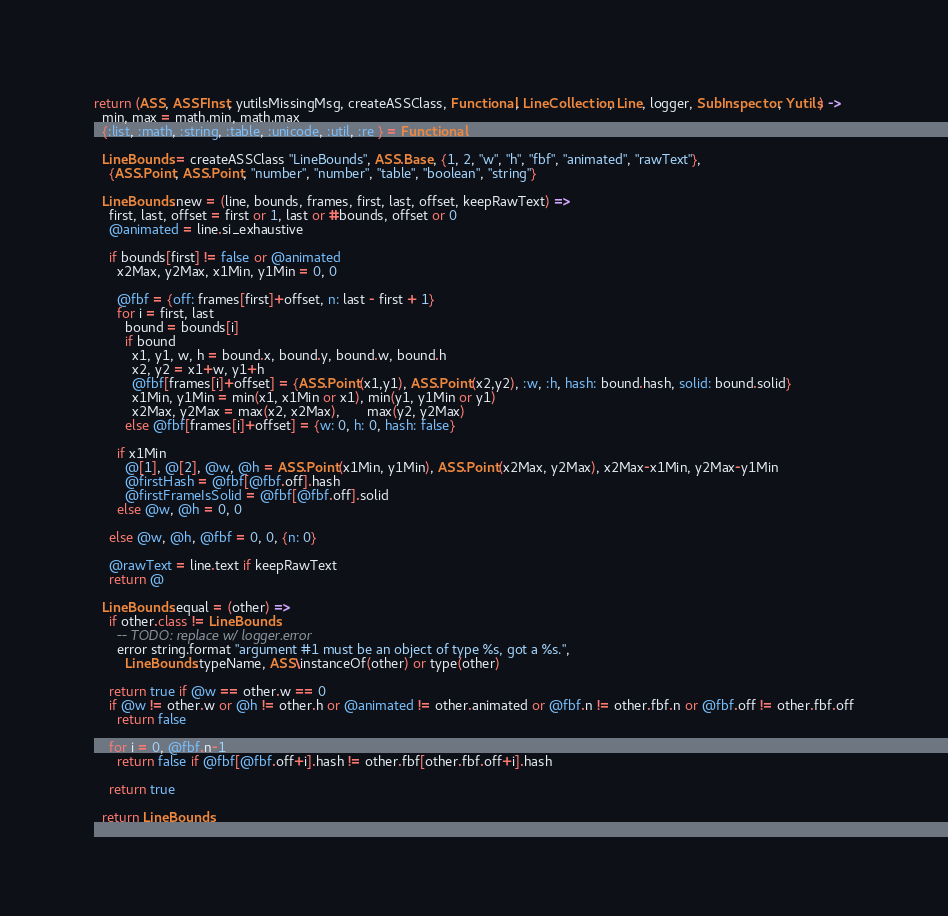<code> <loc_0><loc_0><loc_500><loc_500><_MoonScript_>return (ASS, ASSFInst, yutilsMissingMsg, createASSClass, Functional, LineCollection, Line, logger, SubInspector, Yutils) ->
  min, max = math.min, math.max
  {:list, :math, :string, :table, :unicode, :util, :re } = Functional

  LineBounds = createASSClass "LineBounds", ASS.Base, {1, 2, "w", "h", "fbf", "animated", "rawText"},
    {ASS.Point, ASS.Point, "number", "number", "table", "boolean", "string"}

  LineBounds.new = (line, bounds, frames, first, last, offset, keepRawText) =>
    first, last, offset = first or 1, last or #bounds, offset or 0
    @animated = line.si_exhaustive

    if bounds[first] != false or @animated
      x2Max, y2Max, x1Min, y1Min = 0, 0

      @fbf = {off: frames[first]+offset, n: last - first + 1}
      for i = first, last
        bound = bounds[i]
        if bound
          x1, y1, w, h = bound.x, bound.y, bound.w, bound.h
          x2, y2 = x1+w, y1+h
          @fbf[frames[i]+offset] = {ASS.Point(x1,y1), ASS.Point(x2,y2), :w, :h, hash: bound.hash, solid: bound.solid}
          x1Min, y1Min = min(x1, x1Min or x1), min(y1, y1Min or y1)
          x2Max, y2Max = max(x2, x2Max),       max(y2, y2Max)
        else @fbf[frames[i]+offset] = {w: 0, h: 0, hash: false}

      if x1Min
        @[1], @[2], @w, @h = ASS.Point(x1Min, y1Min), ASS.Point(x2Max, y2Max), x2Max-x1Min, y2Max-y1Min
        @firstHash = @fbf[@fbf.off].hash
        @firstFrameIsSolid = @fbf[@fbf.off].solid
      else @w, @h = 0, 0

    else @w, @h, @fbf = 0, 0, {n: 0}

    @rawText = line.text if keepRawText
    return @

  LineBounds.equal = (other) =>
    if other.class != LineBounds
      -- TODO: replace w/ logger.error
      error string.format "argument #1 must be an object of type %s, got a %s.",
        LineBounds.typeName, ASS\instanceOf(other) or type(other)

    return true if @w == other.w == 0
    if @w != other.w or @h != other.h or @animated != other.animated or @fbf.n != other.fbf.n or @fbf.off != other.fbf.off
      return false

    for i = 0, @fbf.n-1
      return false if @fbf[@fbf.off+i].hash != other.fbf[other.fbf.off+i].hash

    return true

  return LineBounds
</code> 